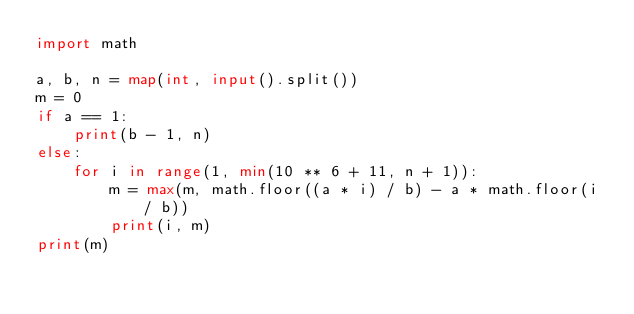<code> <loc_0><loc_0><loc_500><loc_500><_Python_>import math

a, b, n = map(int, input().split())
m = 0
if a == 1:
    print(b - 1, n)
else:
    for i in range(1, min(10 ** 6 + 11, n + 1)):
        m = max(m, math.floor((a * i) / b) - a * math.floor(i / b))
        print(i, m)
print(m)
</code> 